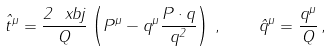<formula> <loc_0><loc_0><loc_500><loc_500>\hat { t } ^ { \mu } = \frac { 2 \ x b j } { Q } \left ( P ^ { \mu } - q ^ { \mu } \frac { P \cdot q } { q ^ { 2 } } \right ) \, , \quad \hat { q } ^ { \mu } = \frac { q ^ { \mu } } { Q } \, ,</formula> 